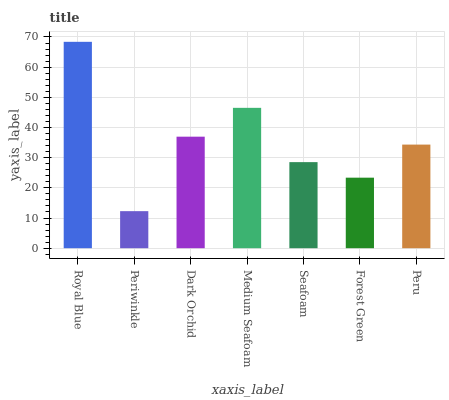Is Periwinkle the minimum?
Answer yes or no. Yes. Is Royal Blue the maximum?
Answer yes or no. Yes. Is Dark Orchid the minimum?
Answer yes or no. No. Is Dark Orchid the maximum?
Answer yes or no. No. Is Dark Orchid greater than Periwinkle?
Answer yes or no. Yes. Is Periwinkle less than Dark Orchid?
Answer yes or no. Yes. Is Periwinkle greater than Dark Orchid?
Answer yes or no. No. Is Dark Orchid less than Periwinkle?
Answer yes or no. No. Is Peru the high median?
Answer yes or no. Yes. Is Peru the low median?
Answer yes or no. Yes. Is Periwinkle the high median?
Answer yes or no. No. Is Dark Orchid the low median?
Answer yes or no. No. 